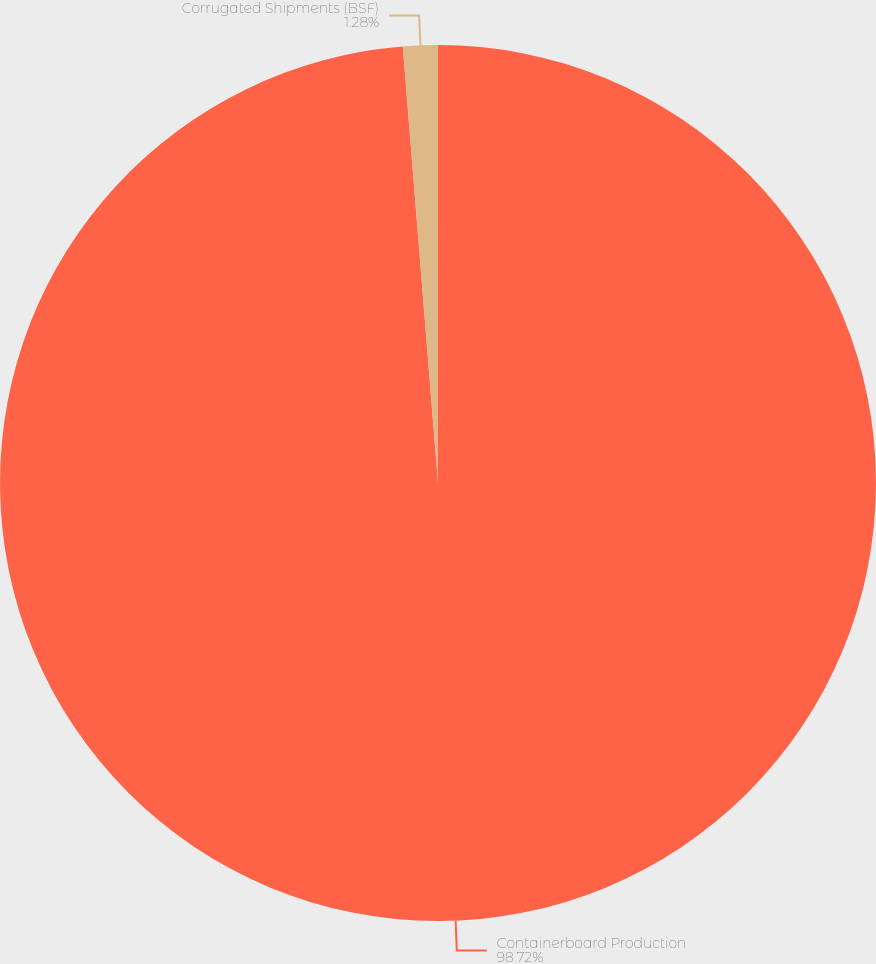Convert chart to OTSL. <chart><loc_0><loc_0><loc_500><loc_500><pie_chart><fcel>Containerboard Production<fcel>Corrugated Shipments (BSF)<nl><fcel>98.72%<fcel>1.28%<nl></chart> 